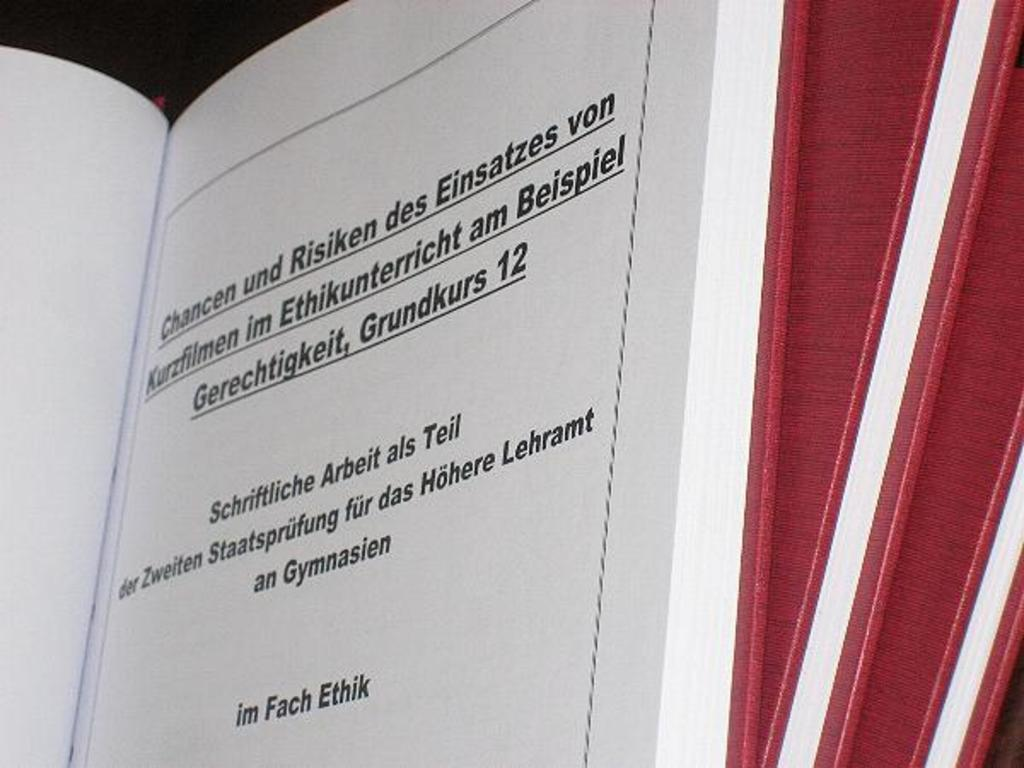<image>
Describe the image concisely. A stack of red books with one open to a title page. 